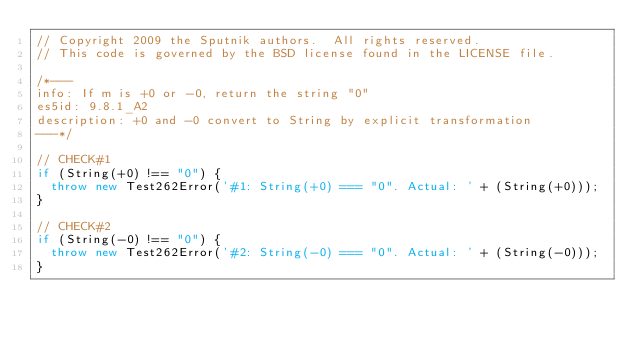<code> <loc_0><loc_0><loc_500><loc_500><_JavaScript_>// Copyright 2009 the Sputnik authors.  All rights reserved.
// This code is governed by the BSD license found in the LICENSE file.

/*---
info: If m is +0 or -0, return the string "0"
es5id: 9.8.1_A2
description: +0 and -0 convert to String by explicit transformation
---*/

// CHECK#1
if (String(+0) !== "0") {
  throw new Test262Error('#1: String(+0) === "0". Actual: ' + (String(+0)));
}

// CHECK#2
if (String(-0) !== "0") {
  throw new Test262Error('#2: String(-0) === "0". Actual: ' + (String(-0)));
}
</code> 